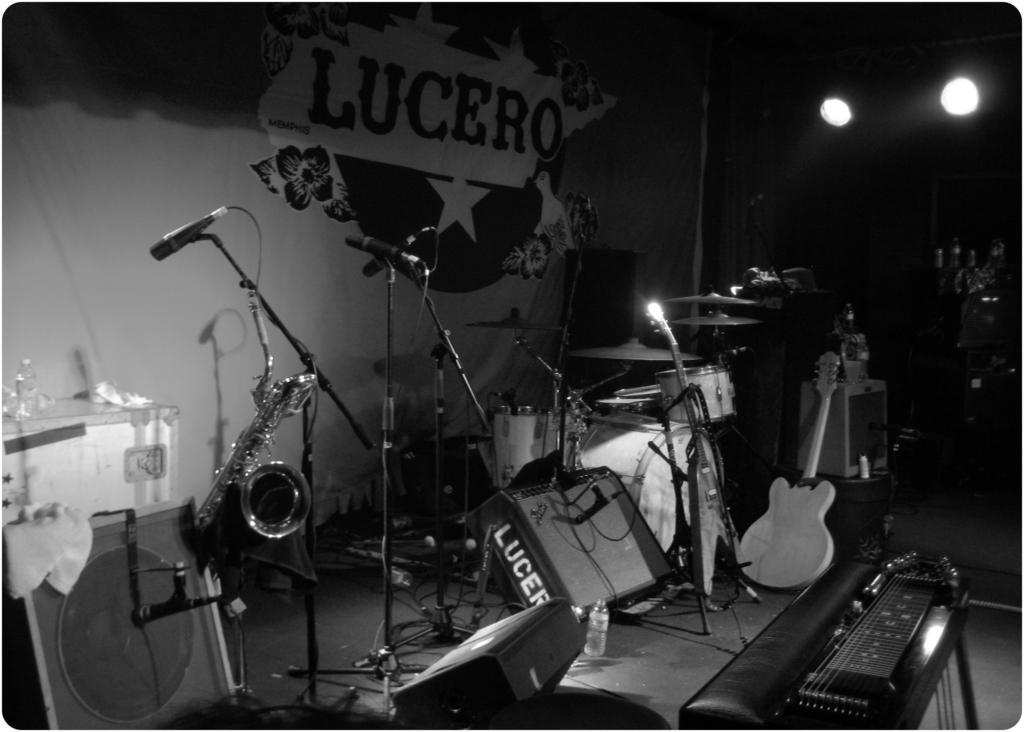How would you summarize this image in a sentence or two? In this image I can see number of musical instruments and mics. 